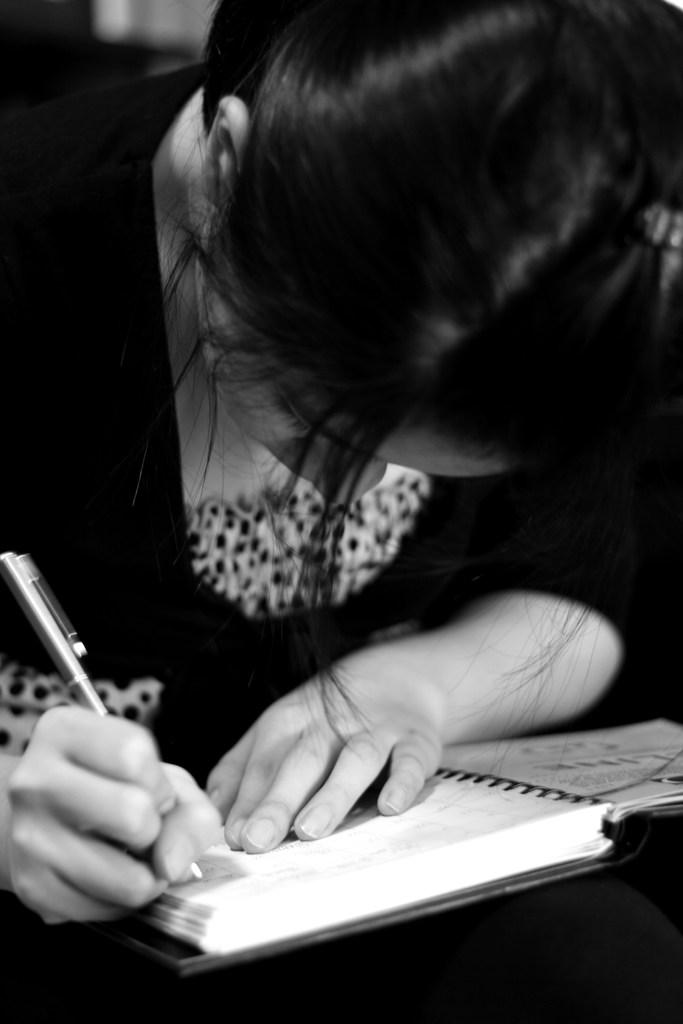What is the main subject of the image? The main subject of the image is a woman. What is the woman doing in the image? The woman is sitting and writing. What is the woman holding in the image? The woman is holding a pen. What might the woman be writing on in the image? There is a book in the image, so the woman might be writing on the book. What is the cause of the snails' migration in the image? There are no snails or migration present in the image. How many thumbs does the woman have on her hand in the image? The image does not show the woman's thumb, so it cannot be determined from the image. 